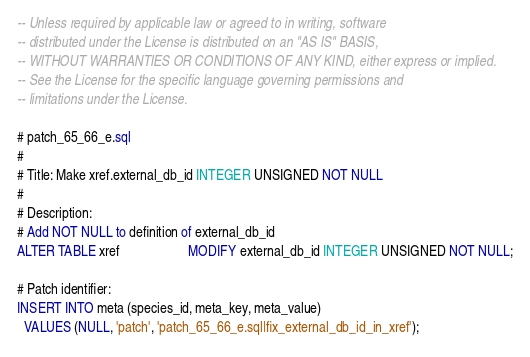Convert code to text. <code><loc_0><loc_0><loc_500><loc_500><_SQL_>-- Unless required by applicable law or agreed to in writing, software
-- distributed under the License is distributed on an "AS IS" BASIS,
-- WITHOUT WARRANTIES OR CONDITIONS OF ANY KIND, either express or implied.
-- See the License for the specific language governing permissions and
-- limitations under the License.

# patch_65_66_e.sql
#
# Title: Make xref.external_db_id INTEGER UNSIGNED NOT NULL
#
# Description:
# Add NOT NULL to definition of external_db_id
ALTER TABLE xref                    MODIFY external_db_id INTEGER UNSIGNED NOT NULL;

# Patch identifier:
INSERT INTO meta (species_id, meta_key, meta_value)
  VALUES (NULL, 'patch', 'patch_65_66_e.sql|fix_external_db_id_in_xref');
</code> 